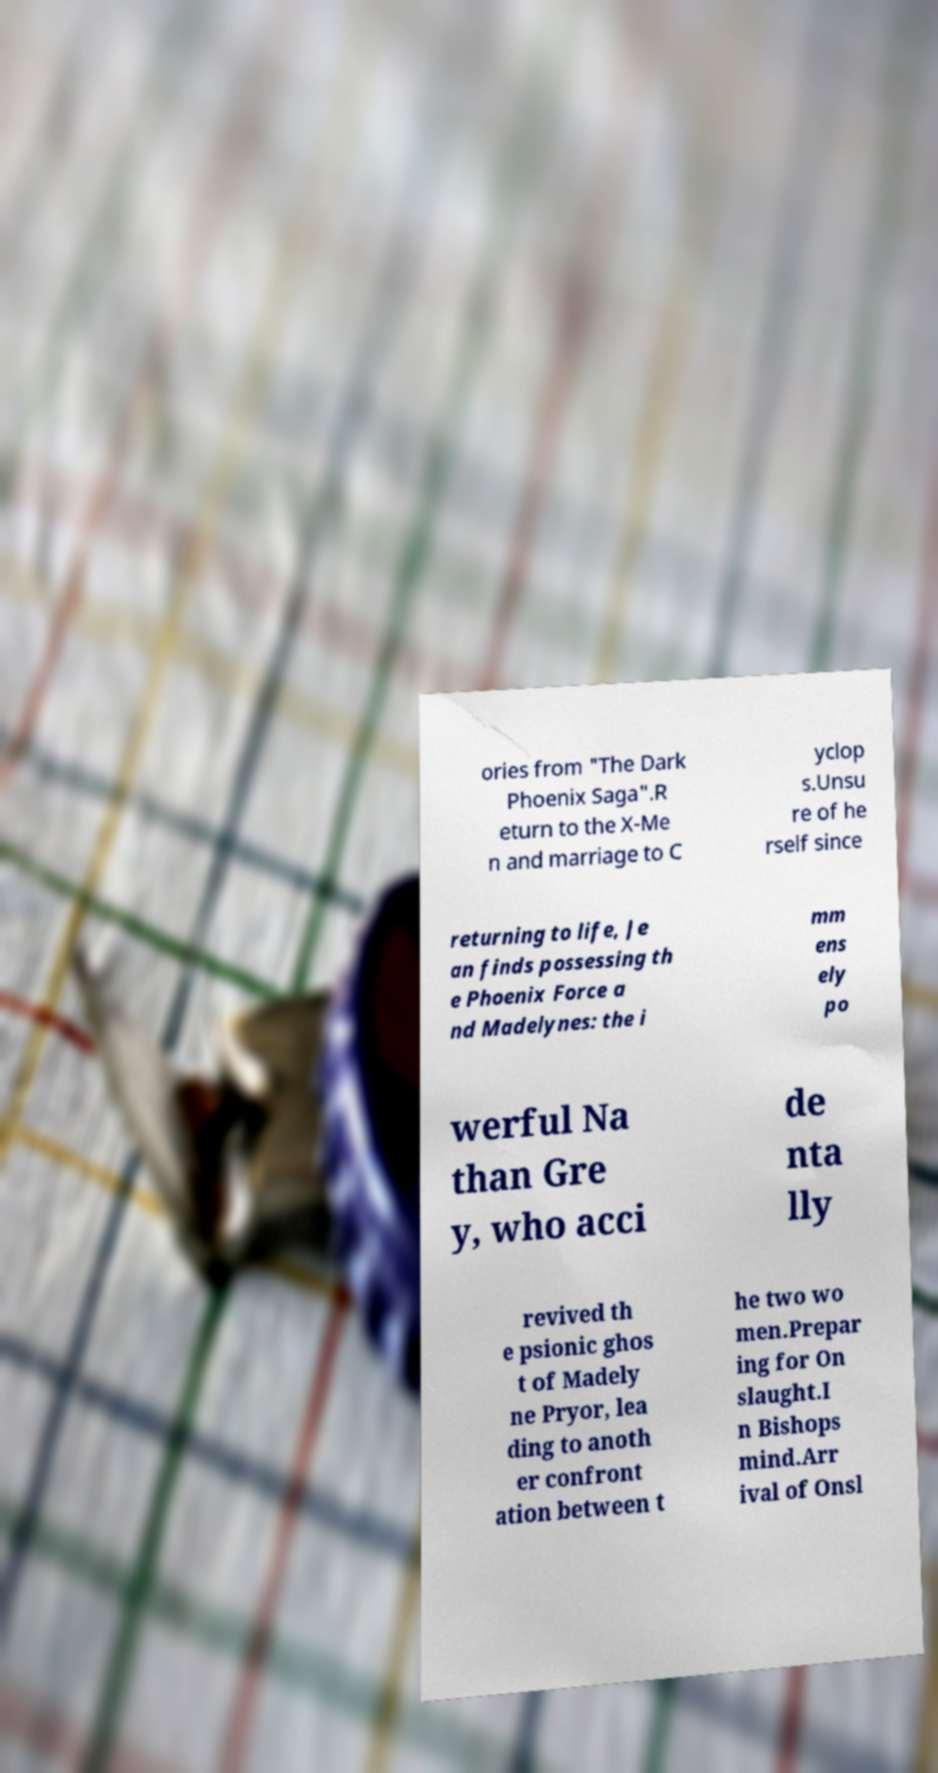There's text embedded in this image that I need extracted. Can you transcribe it verbatim? ories from "The Dark Phoenix Saga".R eturn to the X-Me n and marriage to C yclop s.Unsu re of he rself since returning to life, Je an finds possessing th e Phoenix Force a nd Madelynes: the i mm ens ely po werful Na than Gre y, who acci de nta lly revived th e psionic ghos t of Madely ne Pryor, lea ding to anoth er confront ation between t he two wo men.Prepar ing for On slaught.I n Bishops mind.Arr ival of Onsl 